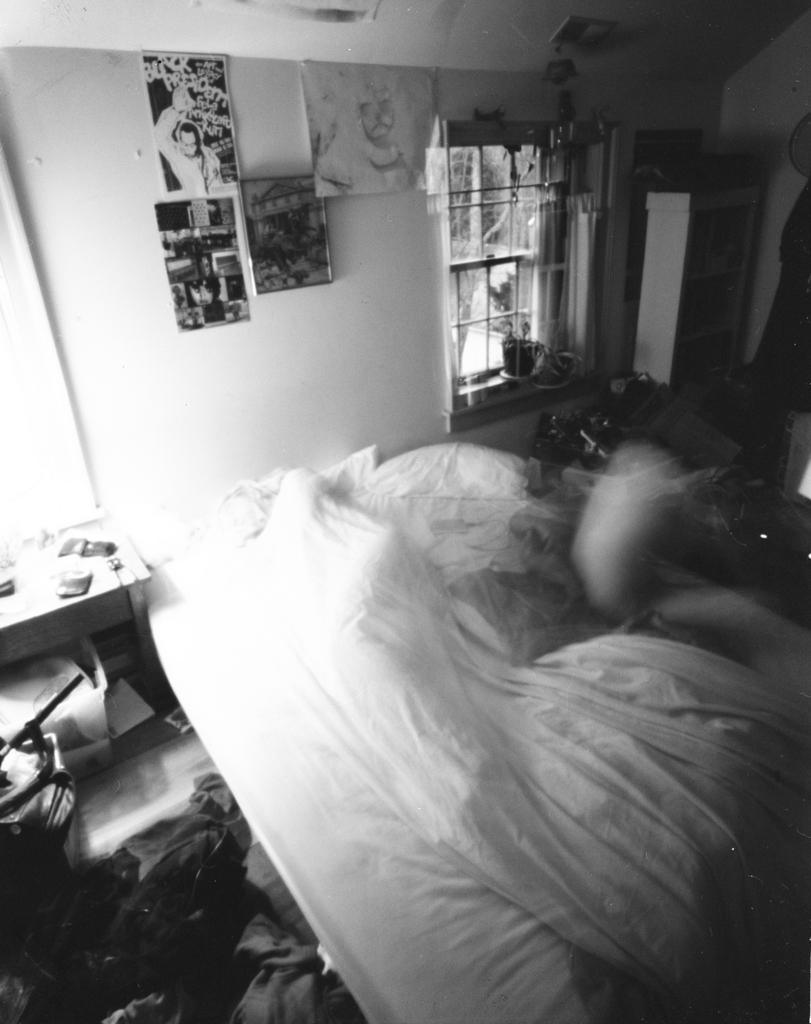What type of space is depicted in the image? The image contains a room. What piece of furniture is present in the room? There is a bed in the room. Can you describe the location of the table in the room? There is a table to the left in the room. What can be seen on the wall in the room? There are posts on the wall in the room. What is located in the right corner of the room? There is an object in the right corner of the room. What number is being whispered by the object in the right corner of the room? There is no indication in the image that the object in the right corner is whispering a number or any other information. 